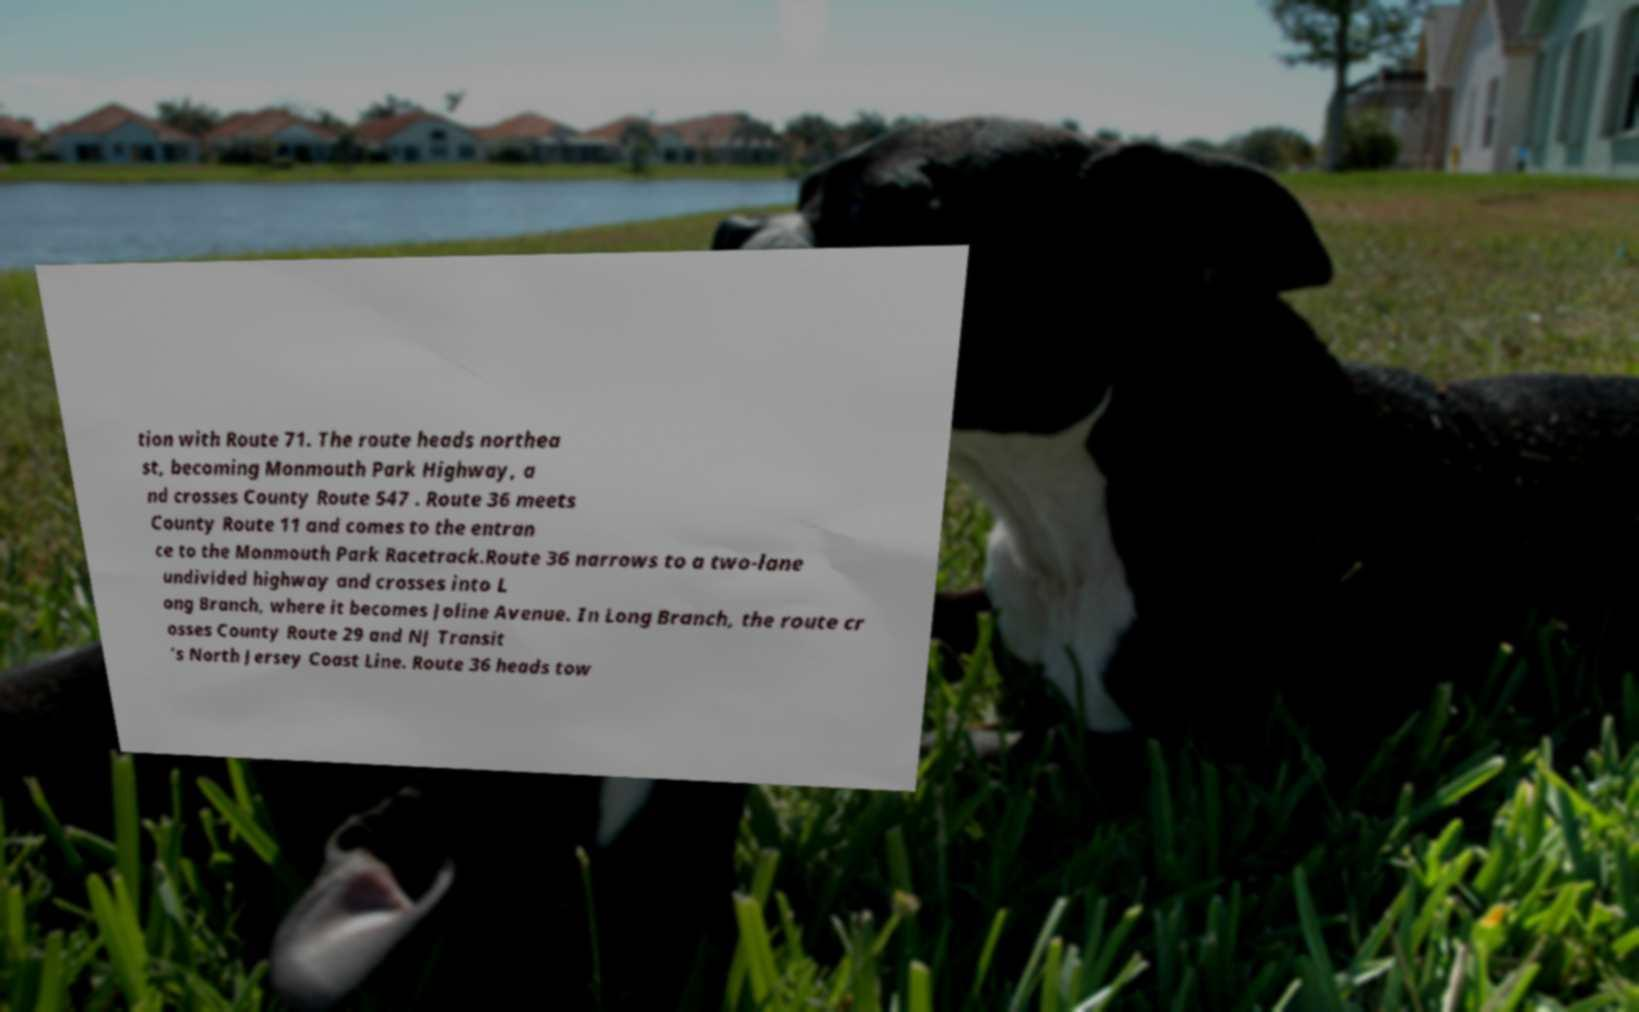Please read and relay the text visible in this image. What does it say? tion with Route 71. The route heads northea st, becoming Monmouth Park Highway, a nd crosses County Route 547 . Route 36 meets County Route 11 and comes to the entran ce to the Monmouth Park Racetrack.Route 36 narrows to a two-lane undivided highway and crosses into L ong Branch, where it becomes Joline Avenue. In Long Branch, the route cr osses County Route 29 and NJ Transit ’s North Jersey Coast Line. Route 36 heads tow 